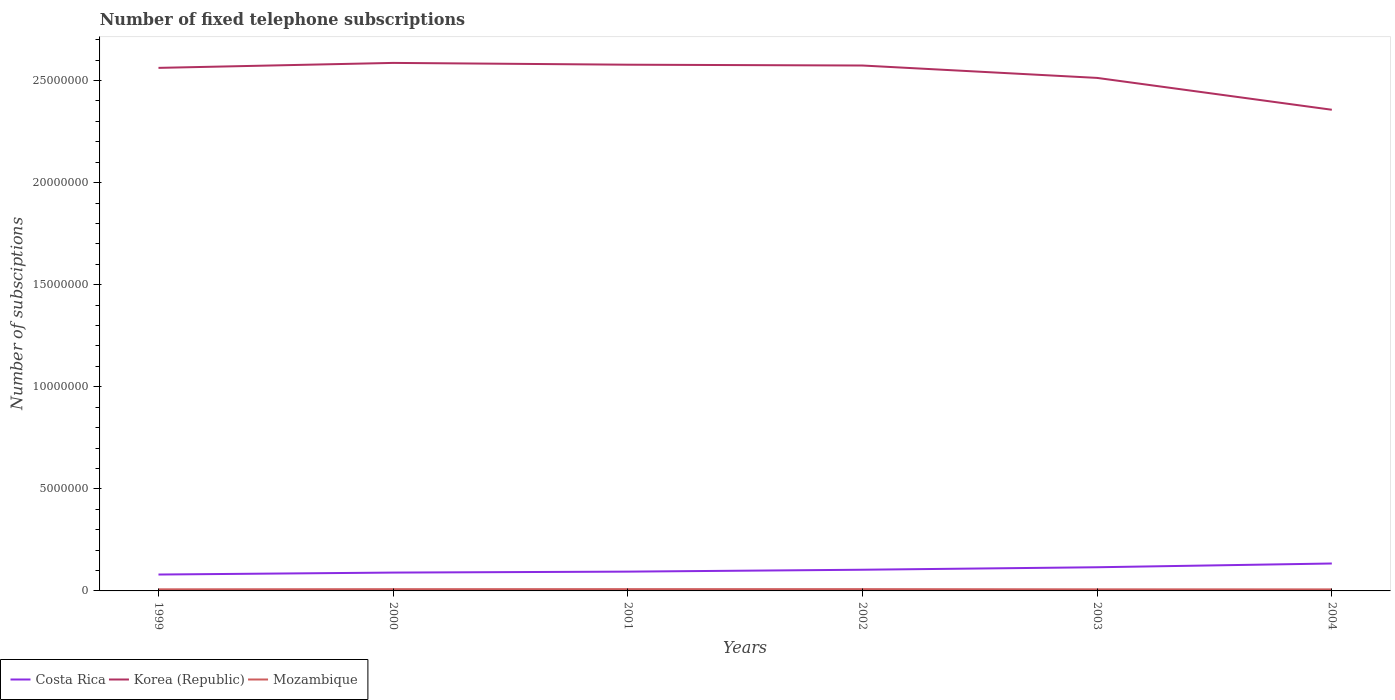Does the line corresponding to Mozambique intersect with the line corresponding to Korea (Republic)?
Your answer should be compact. No. Is the number of lines equal to the number of legend labels?
Offer a very short reply. Yes. Across all years, what is the maximum number of fixed telephone subscriptions in Mozambique?
Offer a very short reply. 7.53e+04. What is the total number of fixed telephone subscriptions in Korea (Republic) in the graph?
Your response must be concise. -1.16e+05. What is the difference between the highest and the second highest number of fixed telephone subscriptions in Mozambique?
Offer a terse response. 1.21e+04. How many lines are there?
Offer a very short reply. 3. How many years are there in the graph?
Your answer should be very brief. 6. What is the difference between two consecutive major ticks on the Y-axis?
Give a very brief answer. 5.00e+06. Are the values on the major ticks of Y-axis written in scientific E-notation?
Your response must be concise. No. Does the graph contain any zero values?
Your answer should be compact. No. How are the legend labels stacked?
Offer a very short reply. Horizontal. What is the title of the graph?
Offer a very short reply. Number of fixed telephone subscriptions. What is the label or title of the Y-axis?
Provide a short and direct response. Number of subsciptions. What is the Number of subsciptions of Costa Rica in 1999?
Provide a short and direct response. 8.03e+05. What is the Number of subsciptions in Korea (Republic) in 1999?
Offer a very short reply. 2.56e+07. What is the Number of subsciptions of Mozambique in 1999?
Offer a terse response. 7.81e+04. What is the Number of subsciptions in Costa Rica in 2000?
Offer a terse response. 8.99e+05. What is the Number of subsciptions in Korea (Republic) in 2000?
Give a very brief answer. 2.59e+07. What is the Number of subsciptions of Mozambique in 2000?
Your response must be concise. 8.57e+04. What is the Number of subsciptions in Costa Rica in 2001?
Keep it short and to the point. 9.45e+05. What is the Number of subsciptions in Korea (Republic) in 2001?
Offer a terse response. 2.58e+07. What is the Number of subsciptions of Mozambique in 2001?
Offer a very short reply. 8.73e+04. What is the Number of subsciptions of Costa Rica in 2002?
Keep it short and to the point. 1.04e+06. What is the Number of subsciptions in Korea (Republic) in 2002?
Provide a succinct answer. 2.57e+07. What is the Number of subsciptions in Mozambique in 2002?
Make the answer very short. 8.74e+04. What is the Number of subsciptions of Costa Rica in 2003?
Provide a succinct answer. 1.16e+06. What is the Number of subsciptions of Korea (Republic) in 2003?
Offer a terse response. 2.51e+07. What is the Number of subsciptions of Mozambique in 2003?
Offer a very short reply. 7.76e+04. What is the Number of subsciptions in Costa Rica in 2004?
Your answer should be very brief. 1.34e+06. What is the Number of subsciptions of Korea (Republic) in 2004?
Give a very brief answer. 2.36e+07. What is the Number of subsciptions in Mozambique in 2004?
Make the answer very short. 7.53e+04. Across all years, what is the maximum Number of subsciptions in Costa Rica?
Provide a short and direct response. 1.34e+06. Across all years, what is the maximum Number of subsciptions of Korea (Republic)?
Ensure brevity in your answer.  2.59e+07. Across all years, what is the maximum Number of subsciptions of Mozambique?
Provide a succinct answer. 8.74e+04. Across all years, what is the minimum Number of subsciptions of Costa Rica?
Offer a very short reply. 8.03e+05. Across all years, what is the minimum Number of subsciptions in Korea (Republic)?
Offer a terse response. 2.36e+07. Across all years, what is the minimum Number of subsciptions in Mozambique?
Your response must be concise. 7.53e+04. What is the total Number of subsciptions in Costa Rica in the graph?
Offer a very short reply. 6.19e+06. What is the total Number of subsciptions in Korea (Republic) in the graph?
Ensure brevity in your answer.  1.52e+08. What is the total Number of subsciptions of Mozambique in the graph?
Ensure brevity in your answer.  4.91e+05. What is the difference between the Number of subsciptions in Costa Rica in 1999 and that in 2000?
Make the answer very short. -9.61e+04. What is the difference between the Number of subsciptions in Korea (Republic) in 1999 and that in 2000?
Your answer should be compact. -2.44e+05. What is the difference between the Number of subsciptions of Mozambique in 1999 and that in 2000?
Provide a short and direct response. -7642. What is the difference between the Number of subsciptions of Costa Rica in 1999 and that in 2001?
Give a very brief answer. -1.42e+05. What is the difference between the Number of subsciptions in Korea (Republic) in 1999 and that in 2001?
Provide a short and direct response. -1.56e+05. What is the difference between the Number of subsciptions of Mozambique in 1999 and that in 2001?
Make the answer very short. -9219. What is the difference between the Number of subsciptions in Costa Rica in 1999 and that in 2002?
Offer a terse response. -2.35e+05. What is the difference between the Number of subsciptions of Korea (Republic) in 1999 and that in 2002?
Offer a very short reply. -1.16e+05. What is the difference between the Number of subsciptions in Mozambique in 1999 and that in 2002?
Offer a very short reply. -9295. What is the difference between the Number of subsciptions of Costa Rica in 1999 and that in 2003?
Provide a short and direct response. -3.57e+05. What is the difference between the Number of subsciptions in Korea (Republic) in 1999 and that in 2003?
Your response must be concise. 4.91e+05. What is the difference between the Number of subsciptions of Mozambique in 1999 and that in 2003?
Offer a very short reply. 496. What is the difference between the Number of subsciptions in Costa Rica in 1999 and that in 2004?
Your answer should be compact. -5.41e+05. What is the difference between the Number of subsciptions in Korea (Republic) in 1999 and that in 2004?
Offer a terse response. 2.05e+06. What is the difference between the Number of subsciptions in Mozambique in 1999 and that in 2004?
Provide a succinct answer. 2816. What is the difference between the Number of subsciptions in Costa Rica in 2000 and that in 2001?
Provide a short and direct response. -4.62e+04. What is the difference between the Number of subsciptions in Korea (Republic) in 2000 and that in 2001?
Your answer should be compact. 8.80e+04. What is the difference between the Number of subsciptions of Mozambique in 2000 and that in 2001?
Provide a short and direct response. -1577. What is the difference between the Number of subsciptions in Costa Rica in 2000 and that in 2002?
Offer a terse response. -1.39e+05. What is the difference between the Number of subsciptions of Korea (Republic) in 2000 and that in 2002?
Ensure brevity in your answer.  1.28e+05. What is the difference between the Number of subsciptions of Mozambique in 2000 and that in 2002?
Keep it short and to the point. -1653. What is the difference between the Number of subsciptions of Costa Rica in 2000 and that in 2003?
Make the answer very short. -2.60e+05. What is the difference between the Number of subsciptions of Korea (Republic) in 2000 and that in 2003?
Offer a very short reply. 7.35e+05. What is the difference between the Number of subsciptions of Mozambique in 2000 and that in 2003?
Offer a very short reply. 8138. What is the difference between the Number of subsciptions of Costa Rica in 2000 and that in 2004?
Provide a succinct answer. -4.44e+05. What is the difference between the Number of subsciptions of Korea (Republic) in 2000 and that in 2004?
Make the answer very short. 2.30e+06. What is the difference between the Number of subsciptions of Mozambique in 2000 and that in 2004?
Your answer should be compact. 1.05e+04. What is the difference between the Number of subsciptions in Costa Rica in 2001 and that in 2002?
Offer a very short reply. -9.30e+04. What is the difference between the Number of subsciptions of Korea (Republic) in 2001 and that in 2002?
Offer a terse response. 4.00e+04. What is the difference between the Number of subsciptions in Mozambique in 2001 and that in 2002?
Provide a succinct answer. -76. What is the difference between the Number of subsciptions in Costa Rica in 2001 and that in 2003?
Provide a succinct answer. -2.14e+05. What is the difference between the Number of subsciptions of Korea (Republic) in 2001 and that in 2003?
Make the answer very short. 6.47e+05. What is the difference between the Number of subsciptions of Mozambique in 2001 and that in 2003?
Your answer should be compact. 9715. What is the difference between the Number of subsciptions in Costa Rica in 2001 and that in 2004?
Offer a very short reply. -3.98e+05. What is the difference between the Number of subsciptions in Korea (Republic) in 2001 and that in 2004?
Your answer should be very brief. 2.21e+06. What is the difference between the Number of subsciptions in Mozambique in 2001 and that in 2004?
Your answer should be very brief. 1.20e+04. What is the difference between the Number of subsciptions in Costa Rica in 2002 and that in 2003?
Make the answer very short. -1.21e+05. What is the difference between the Number of subsciptions in Korea (Republic) in 2002 and that in 2003?
Ensure brevity in your answer.  6.07e+05. What is the difference between the Number of subsciptions in Mozambique in 2002 and that in 2003?
Your answer should be compact. 9791. What is the difference between the Number of subsciptions in Costa Rica in 2002 and that in 2004?
Your answer should be compact. -3.05e+05. What is the difference between the Number of subsciptions of Korea (Republic) in 2002 and that in 2004?
Ensure brevity in your answer.  2.17e+06. What is the difference between the Number of subsciptions in Mozambique in 2002 and that in 2004?
Your response must be concise. 1.21e+04. What is the difference between the Number of subsciptions in Costa Rica in 2003 and that in 2004?
Offer a terse response. -1.84e+05. What is the difference between the Number of subsciptions of Korea (Republic) in 2003 and that in 2004?
Offer a terse response. 1.56e+06. What is the difference between the Number of subsciptions in Mozambique in 2003 and that in 2004?
Your response must be concise. 2320. What is the difference between the Number of subsciptions of Costa Rica in 1999 and the Number of subsciptions of Korea (Republic) in 2000?
Give a very brief answer. -2.51e+07. What is the difference between the Number of subsciptions of Costa Rica in 1999 and the Number of subsciptions of Mozambique in 2000?
Offer a terse response. 7.17e+05. What is the difference between the Number of subsciptions of Korea (Republic) in 1999 and the Number of subsciptions of Mozambique in 2000?
Provide a succinct answer. 2.55e+07. What is the difference between the Number of subsciptions of Costa Rica in 1999 and the Number of subsciptions of Korea (Republic) in 2001?
Your answer should be compact. -2.50e+07. What is the difference between the Number of subsciptions of Costa Rica in 1999 and the Number of subsciptions of Mozambique in 2001?
Offer a terse response. 7.15e+05. What is the difference between the Number of subsciptions of Korea (Republic) in 1999 and the Number of subsciptions of Mozambique in 2001?
Ensure brevity in your answer.  2.55e+07. What is the difference between the Number of subsciptions in Costa Rica in 1999 and the Number of subsciptions in Korea (Republic) in 2002?
Your answer should be very brief. -2.49e+07. What is the difference between the Number of subsciptions in Costa Rica in 1999 and the Number of subsciptions in Mozambique in 2002?
Provide a succinct answer. 7.15e+05. What is the difference between the Number of subsciptions of Korea (Republic) in 1999 and the Number of subsciptions of Mozambique in 2002?
Keep it short and to the point. 2.55e+07. What is the difference between the Number of subsciptions in Costa Rica in 1999 and the Number of subsciptions in Korea (Republic) in 2003?
Your answer should be very brief. -2.43e+07. What is the difference between the Number of subsciptions of Costa Rica in 1999 and the Number of subsciptions of Mozambique in 2003?
Your answer should be very brief. 7.25e+05. What is the difference between the Number of subsciptions in Korea (Republic) in 1999 and the Number of subsciptions in Mozambique in 2003?
Keep it short and to the point. 2.55e+07. What is the difference between the Number of subsciptions in Costa Rica in 1999 and the Number of subsciptions in Korea (Republic) in 2004?
Provide a succinct answer. -2.28e+07. What is the difference between the Number of subsciptions in Costa Rica in 1999 and the Number of subsciptions in Mozambique in 2004?
Your answer should be compact. 7.27e+05. What is the difference between the Number of subsciptions of Korea (Republic) in 1999 and the Number of subsciptions of Mozambique in 2004?
Ensure brevity in your answer.  2.55e+07. What is the difference between the Number of subsciptions in Costa Rica in 2000 and the Number of subsciptions in Korea (Republic) in 2001?
Make the answer very short. -2.49e+07. What is the difference between the Number of subsciptions of Costa Rica in 2000 and the Number of subsciptions of Mozambique in 2001?
Your answer should be compact. 8.11e+05. What is the difference between the Number of subsciptions in Korea (Republic) in 2000 and the Number of subsciptions in Mozambique in 2001?
Give a very brief answer. 2.58e+07. What is the difference between the Number of subsciptions in Costa Rica in 2000 and the Number of subsciptions in Korea (Republic) in 2002?
Your response must be concise. -2.48e+07. What is the difference between the Number of subsciptions of Costa Rica in 2000 and the Number of subsciptions of Mozambique in 2002?
Provide a succinct answer. 8.11e+05. What is the difference between the Number of subsciptions of Korea (Republic) in 2000 and the Number of subsciptions of Mozambique in 2002?
Offer a terse response. 2.58e+07. What is the difference between the Number of subsciptions in Costa Rica in 2000 and the Number of subsciptions in Korea (Republic) in 2003?
Provide a succinct answer. -2.42e+07. What is the difference between the Number of subsciptions in Costa Rica in 2000 and the Number of subsciptions in Mozambique in 2003?
Keep it short and to the point. 8.21e+05. What is the difference between the Number of subsciptions of Korea (Republic) in 2000 and the Number of subsciptions of Mozambique in 2003?
Ensure brevity in your answer.  2.58e+07. What is the difference between the Number of subsciptions in Costa Rica in 2000 and the Number of subsciptions in Korea (Republic) in 2004?
Your response must be concise. -2.27e+07. What is the difference between the Number of subsciptions of Costa Rica in 2000 and the Number of subsciptions of Mozambique in 2004?
Offer a terse response. 8.23e+05. What is the difference between the Number of subsciptions of Korea (Republic) in 2000 and the Number of subsciptions of Mozambique in 2004?
Give a very brief answer. 2.58e+07. What is the difference between the Number of subsciptions in Costa Rica in 2001 and the Number of subsciptions in Korea (Republic) in 2002?
Your response must be concise. -2.48e+07. What is the difference between the Number of subsciptions of Costa Rica in 2001 and the Number of subsciptions of Mozambique in 2002?
Give a very brief answer. 8.58e+05. What is the difference between the Number of subsciptions of Korea (Republic) in 2001 and the Number of subsciptions of Mozambique in 2002?
Offer a very short reply. 2.57e+07. What is the difference between the Number of subsciptions in Costa Rica in 2001 and the Number of subsciptions in Korea (Republic) in 2003?
Offer a very short reply. -2.42e+07. What is the difference between the Number of subsciptions in Costa Rica in 2001 and the Number of subsciptions in Mozambique in 2003?
Offer a very short reply. 8.67e+05. What is the difference between the Number of subsciptions of Korea (Republic) in 2001 and the Number of subsciptions of Mozambique in 2003?
Offer a terse response. 2.57e+07. What is the difference between the Number of subsciptions in Costa Rica in 2001 and the Number of subsciptions in Korea (Republic) in 2004?
Give a very brief answer. -2.26e+07. What is the difference between the Number of subsciptions of Costa Rica in 2001 and the Number of subsciptions of Mozambique in 2004?
Keep it short and to the point. 8.70e+05. What is the difference between the Number of subsciptions of Korea (Republic) in 2001 and the Number of subsciptions of Mozambique in 2004?
Your answer should be compact. 2.57e+07. What is the difference between the Number of subsciptions of Costa Rica in 2002 and the Number of subsciptions of Korea (Republic) in 2003?
Your answer should be very brief. -2.41e+07. What is the difference between the Number of subsciptions in Costa Rica in 2002 and the Number of subsciptions in Mozambique in 2003?
Keep it short and to the point. 9.60e+05. What is the difference between the Number of subsciptions of Korea (Republic) in 2002 and the Number of subsciptions of Mozambique in 2003?
Your answer should be very brief. 2.57e+07. What is the difference between the Number of subsciptions in Costa Rica in 2002 and the Number of subsciptions in Korea (Republic) in 2004?
Offer a very short reply. -2.25e+07. What is the difference between the Number of subsciptions of Costa Rica in 2002 and the Number of subsciptions of Mozambique in 2004?
Keep it short and to the point. 9.63e+05. What is the difference between the Number of subsciptions of Korea (Republic) in 2002 and the Number of subsciptions of Mozambique in 2004?
Offer a terse response. 2.57e+07. What is the difference between the Number of subsciptions of Costa Rica in 2003 and the Number of subsciptions of Korea (Republic) in 2004?
Offer a very short reply. -2.24e+07. What is the difference between the Number of subsciptions of Costa Rica in 2003 and the Number of subsciptions of Mozambique in 2004?
Offer a very short reply. 1.08e+06. What is the difference between the Number of subsciptions in Korea (Republic) in 2003 and the Number of subsciptions in Mozambique in 2004?
Ensure brevity in your answer.  2.51e+07. What is the average Number of subsciptions in Costa Rica per year?
Your answer should be very brief. 1.03e+06. What is the average Number of subsciptions of Korea (Republic) per year?
Your answer should be very brief. 2.53e+07. What is the average Number of subsciptions in Mozambique per year?
Provide a short and direct response. 8.19e+04. In the year 1999, what is the difference between the Number of subsciptions of Costa Rica and Number of subsciptions of Korea (Republic)?
Make the answer very short. -2.48e+07. In the year 1999, what is the difference between the Number of subsciptions in Costa Rica and Number of subsciptions in Mozambique?
Ensure brevity in your answer.  7.25e+05. In the year 1999, what is the difference between the Number of subsciptions of Korea (Republic) and Number of subsciptions of Mozambique?
Your response must be concise. 2.55e+07. In the year 2000, what is the difference between the Number of subsciptions of Costa Rica and Number of subsciptions of Korea (Republic)?
Offer a very short reply. -2.50e+07. In the year 2000, what is the difference between the Number of subsciptions in Costa Rica and Number of subsciptions in Mozambique?
Offer a very short reply. 8.13e+05. In the year 2000, what is the difference between the Number of subsciptions of Korea (Republic) and Number of subsciptions of Mozambique?
Make the answer very short. 2.58e+07. In the year 2001, what is the difference between the Number of subsciptions of Costa Rica and Number of subsciptions of Korea (Republic)?
Keep it short and to the point. -2.48e+07. In the year 2001, what is the difference between the Number of subsciptions of Costa Rica and Number of subsciptions of Mozambique?
Your answer should be very brief. 8.58e+05. In the year 2001, what is the difference between the Number of subsciptions of Korea (Republic) and Number of subsciptions of Mozambique?
Offer a terse response. 2.57e+07. In the year 2002, what is the difference between the Number of subsciptions in Costa Rica and Number of subsciptions in Korea (Republic)?
Make the answer very short. -2.47e+07. In the year 2002, what is the difference between the Number of subsciptions in Costa Rica and Number of subsciptions in Mozambique?
Keep it short and to the point. 9.51e+05. In the year 2002, what is the difference between the Number of subsciptions of Korea (Republic) and Number of subsciptions of Mozambique?
Provide a short and direct response. 2.56e+07. In the year 2003, what is the difference between the Number of subsciptions of Costa Rica and Number of subsciptions of Korea (Republic)?
Make the answer very short. -2.40e+07. In the year 2003, what is the difference between the Number of subsciptions of Costa Rica and Number of subsciptions of Mozambique?
Your response must be concise. 1.08e+06. In the year 2003, what is the difference between the Number of subsciptions in Korea (Republic) and Number of subsciptions in Mozambique?
Make the answer very short. 2.51e+07. In the year 2004, what is the difference between the Number of subsciptions in Costa Rica and Number of subsciptions in Korea (Republic)?
Offer a very short reply. -2.22e+07. In the year 2004, what is the difference between the Number of subsciptions in Costa Rica and Number of subsciptions in Mozambique?
Your answer should be compact. 1.27e+06. In the year 2004, what is the difference between the Number of subsciptions in Korea (Republic) and Number of subsciptions in Mozambique?
Your answer should be very brief. 2.35e+07. What is the ratio of the Number of subsciptions of Costa Rica in 1999 to that in 2000?
Give a very brief answer. 0.89. What is the ratio of the Number of subsciptions in Korea (Republic) in 1999 to that in 2000?
Keep it short and to the point. 0.99. What is the ratio of the Number of subsciptions in Mozambique in 1999 to that in 2000?
Keep it short and to the point. 0.91. What is the ratio of the Number of subsciptions of Costa Rica in 1999 to that in 2001?
Your answer should be very brief. 0.85. What is the ratio of the Number of subsciptions of Korea (Republic) in 1999 to that in 2001?
Make the answer very short. 0.99. What is the ratio of the Number of subsciptions of Mozambique in 1999 to that in 2001?
Make the answer very short. 0.89. What is the ratio of the Number of subsciptions in Costa Rica in 1999 to that in 2002?
Provide a short and direct response. 0.77. What is the ratio of the Number of subsciptions of Mozambique in 1999 to that in 2002?
Your answer should be very brief. 0.89. What is the ratio of the Number of subsciptions in Costa Rica in 1999 to that in 2003?
Ensure brevity in your answer.  0.69. What is the ratio of the Number of subsciptions of Korea (Republic) in 1999 to that in 2003?
Ensure brevity in your answer.  1.02. What is the ratio of the Number of subsciptions of Mozambique in 1999 to that in 2003?
Ensure brevity in your answer.  1.01. What is the ratio of the Number of subsciptions of Costa Rica in 1999 to that in 2004?
Ensure brevity in your answer.  0.6. What is the ratio of the Number of subsciptions of Korea (Republic) in 1999 to that in 2004?
Keep it short and to the point. 1.09. What is the ratio of the Number of subsciptions of Mozambique in 1999 to that in 2004?
Ensure brevity in your answer.  1.04. What is the ratio of the Number of subsciptions of Costa Rica in 2000 to that in 2001?
Provide a succinct answer. 0.95. What is the ratio of the Number of subsciptions in Mozambique in 2000 to that in 2001?
Ensure brevity in your answer.  0.98. What is the ratio of the Number of subsciptions in Costa Rica in 2000 to that in 2002?
Provide a succinct answer. 0.87. What is the ratio of the Number of subsciptions in Korea (Republic) in 2000 to that in 2002?
Give a very brief answer. 1. What is the ratio of the Number of subsciptions in Mozambique in 2000 to that in 2002?
Give a very brief answer. 0.98. What is the ratio of the Number of subsciptions in Costa Rica in 2000 to that in 2003?
Offer a terse response. 0.78. What is the ratio of the Number of subsciptions in Korea (Republic) in 2000 to that in 2003?
Provide a succinct answer. 1.03. What is the ratio of the Number of subsciptions in Mozambique in 2000 to that in 2003?
Offer a very short reply. 1.1. What is the ratio of the Number of subsciptions in Costa Rica in 2000 to that in 2004?
Your answer should be compact. 0.67. What is the ratio of the Number of subsciptions of Korea (Republic) in 2000 to that in 2004?
Offer a very short reply. 1.1. What is the ratio of the Number of subsciptions in Mozambique in 2000 to that in 2004?
Your answer should be very brief. 1.14. What is the ratio of the Number of subsciptions in Costa Rica in 2001 to that in 2002?
Offer a terse response. 0.91. What is the ratio of the Number of subsciptions of Korea (Republic) in 2001 to that in 2002?
Make the answer very short. 1. What is the ratio of the Number of subsciptions of Costa Rica in 2001 to that in 2003?
Ensure brevity in your answer.  0.82. What is the ratio of the Number of subsciptions in Korea (Republic) in 2001 to that in 2003?
Offer a terse response. 1.03. What is the ratio of the Number of subsciptions in Mozambique in 2001 to that in 2003?
Provide a short and direct response. 1.13. What is the ratio of the Number of subsciptions in Costa Rica in 2001 to that in 2004?
Keep it short and to the point. 0.7. What is the ratio of the Number of subsciptions in Korea (Republic) in 2001 to that in 2004?
Offer a very short reply. 1.09. What is the ratio of the Number of subsciptions in Mozambique in 2001 to that in 2004?
Your answer should be compact. 1.16. What is the ratio of the Number of subsciptions in Costa Rica in 2002 to that in 2003?
Make the answer very short. 0.9. What is the ratio of the Number of subsciptions in Korea (Republic) in 2002 to that in 2003?
Keep it short and to the point. 1.02. What is the ratio of the Number of subsciptions in Mozambique in 2002 to that in 2003?
Make the answer very short. 1.13. What is the ratio of the Number of subsciptions of Costa Rica in 2002 to that in 2004?
Make the answer very short. 0.77. What is the ratio of the Number of subsciptions in Korea (Republic) in 2002 to that in 2004?
Ensure brevity in your answer.  1.09. What is the ratio of the Number of subsciptions in Mozambique in 2002 to that in 2004?
Make the answer very short. 1.16. What is the ratio of the Number of subsciptions in Costa Rica in 2003 to that in 2004?
Keep it short and to the point. 0.86. What is the ratio of the Number of subsciptions of Korea (Republic) in 2003 to that in 2004?
Your answer should be very brief. 1.07. What is the ratio of the Number of subsciptions of Mozambique in 2003 to that in 2004?
Provide a short and direct response. 1.03. What is the difference between the highest and the second highest Number of subsciptions in Costa Rica?
Provide a short and direct response. 1.84e+05. What is the difference between the highest and the second highest Number of subsciptions of Korea (Republic)?
Offer a very short reply. 8.80e+04. What is the difference between the highest and the second highest Number of subsciptions of Mozambique?
Provide a succinct answer. 76. What is the difference between the highest and the lowest Number of subsciptions in Costa Rica?
Your answer should be compact. 5.41e+05. What is the difference between the highest and the lowest Number of subsciptions of Korea (Republic)?
Keep it short and to the point. 2.30e+06. What is the difference between the highest and the lowest Number of subsciptions in Mozambique?
Give a very brief answer. 1.21e+04. 